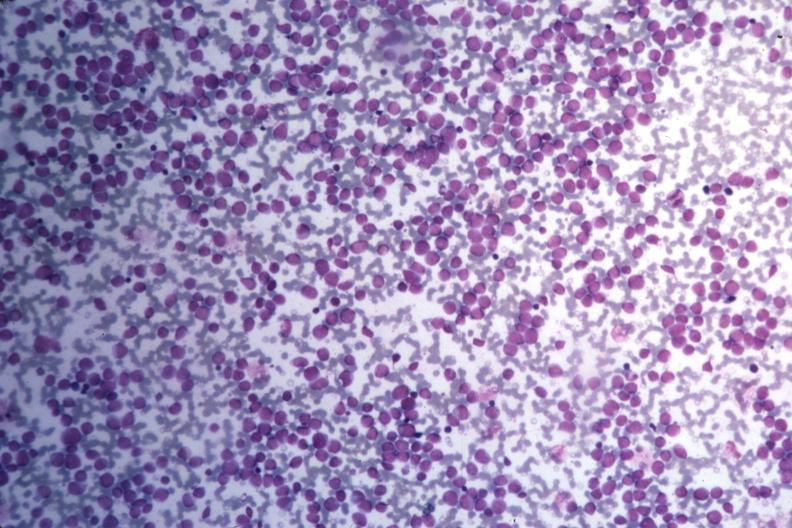what is present?
Answer the question using a single word or phrase. Acute myelogenous leukemia 